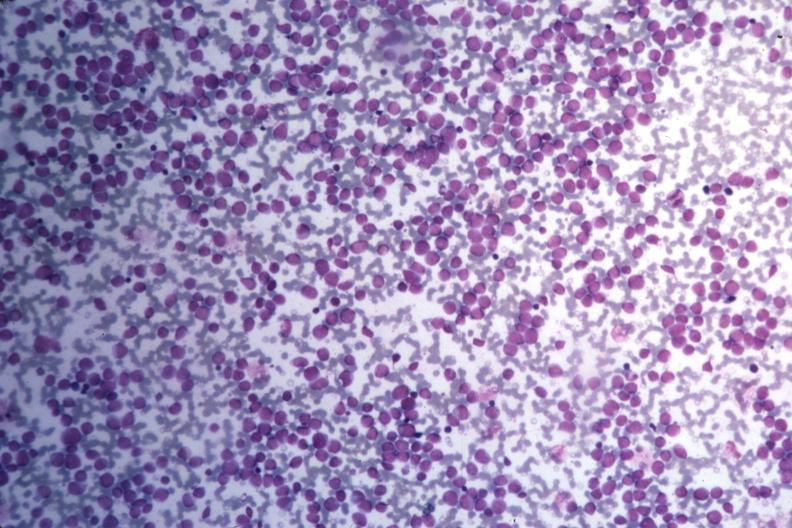what is present?
Answer the question using a single word or phrase. Acute myelogenous leukemia 